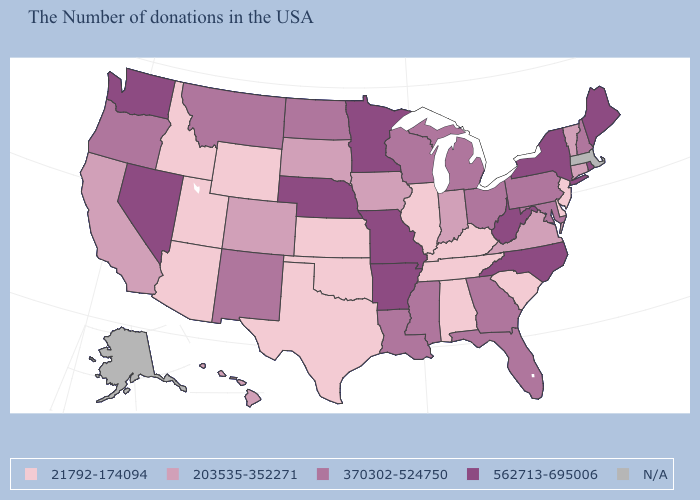Among the states that border Pennsylvania , which have the highest value?
Give a very brief answer. New York, West Virginia. What is the highest value in the Northeast ?
Write a very short answer. 562713-695006. What is the value of Massachusetts?
Be succinct. N/A. What is the value of Louisiana?
Keep it brief. 370302-524750. Does Idaho have the lowest value in the West?
Short answer required. Yes. How many symbols are there in the legend?
Quick response, please. 5. What is the value of Georgia?
Quick response, please. 370302-524750. Name the states that have a value in the range 370302-524750?
Be succinct. New Hampshire, Maryland, Pennsylvania, Ohio, Florida, Georgia, Michigan, Wisconsin, Mississippi, Louisiana, North Dakota, New Mexico, Montana, Oregon. What is the value of Tennessee?
Concise answer only. 21792-174094. Among the states that border Georgia , does Alabama have the lowest value?
Short answer required. Yes. Name the states that have a value in the range 203535-352271?
Answer briefly. Vermont, Connecticut, Virginia, Indiana, Iowa, South Dakota, Colorado, California, Hawaii. What is the lowest value in the West?
Give a very brief answer. 21792-174094. Does West Virginia have the lowest value in the South?
Give a very brief answer. No. Which states have the lowest value in the Northeast?
Concise answer only. New Jersey. 